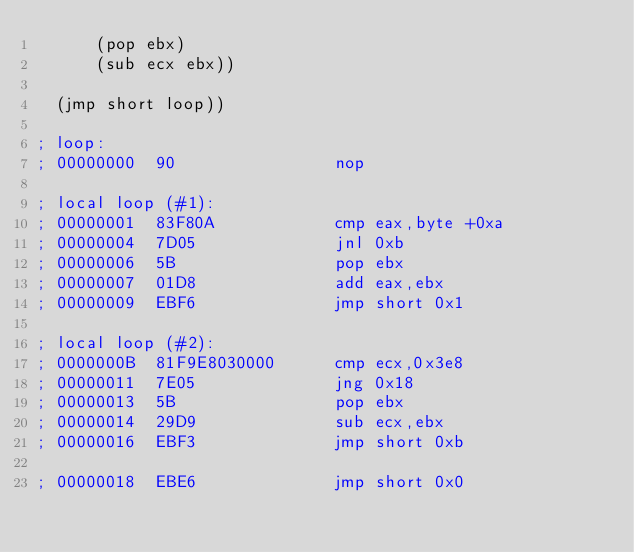<code> <loc_0><loc_0><loc_500><loc_500><_Scheme_>	    (pop ebx)
	    (sub ecx ebx))

  (jmp short loop))

; loop:
; 00000000  90                nop

; local loop (#1):
; 00000001  83F80A            cmp eax,byte +0xa
; 00000004  7D05              jnl 0xb
; 00000006  5B                pop ebx
; 00000007  01D8              add eax,ebx
; 00000009  EBF6              jmp short 0x1

; local loop (#2):
; 0000000B  81F9E8030000      cmp ecx,0x3e8
; 00000011  7E05              jng 0x18
; 00000013  5B                pop ebx
; 00000014  29D9              sub ecx,ebx
; 00000016  EBF3              jmp short 0xb

; 00000018  EBE6              jmp short 0x0
</code> 